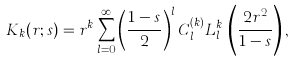Convert formula to latex. <formula><loc_0><loc_0><loc_500><loc_500>K _ { k } ( r ; s ) = r ^ { k } \sum _ { l = 0 } ^ { \infty } \left ( \frac { 1 - s } { 2 } \right ) ^ { l } C _ { l } ^ { ( k ) } L _ { l } ^ { k } \, \left ( \frac { 2 r ^ { 2 } } { 1 - s } \right ) ,</formula> 